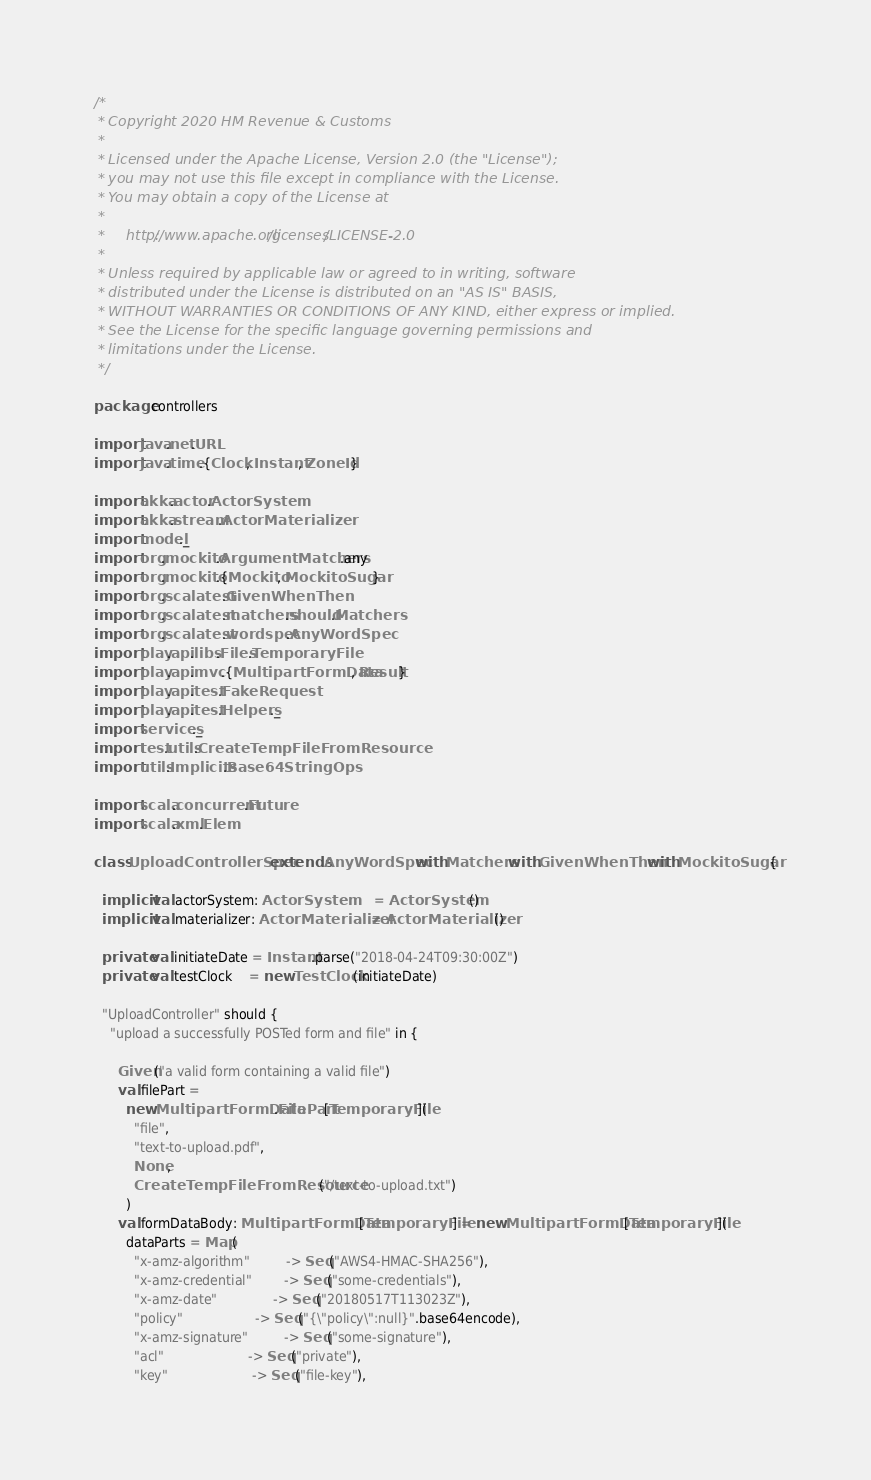<code> <loc_0><loc_0><loc_500><loc_500><_Scala_>/*
 * Copyright 2020 HM Revenue & Customs
 *
 * Licensed under the Apache License, Version 2.0 (the "License");
 * you may not use this file except in compliance with the License.
 * You may obtain a copy of the License at
 *
 *     http://www.apache.org/licenses/LICENSE-2.0
 *
 * Unless required by applicable law or agreed to in writing, software
 * distributed under the License is distributed on an "AS IS" BASIS,
 * WITHOUT WARRANTIES OR CONDITIONS OF ANY KIND, either express or implied.
 * See the License for the specific language governing permissions and
 * limitations under the License.
 */

package controllers

import java.net.URL
import java.time.{Clock, Instant, ZoneId}

import akka.actor.ActorSystem
import akka.stream.ActorMaterializer
import model._
import org.mockito.ArgumentMatchers.any
import org.mockito.{Mockito, MockitoSugar}
import org.scalatest.GivenWhenThen
import org.scalatest.matchers.should.Matchers
import org.scalatest.wordspec.AnyWordSpec
import play.api.libs.Files.TemporaryFile
import play.api.mvc.{MultipartFormData, Result}
import play.api.test.FakeRequest
import play.api.test.Helpers._
import services._
import test.utils.CreateTempFileFromResource
import utils.Implicits.Base64StringOps

import scala.concurrent.Future
import scala.xml.Elem

class UploadControllerSpec extends AnyWordSpec with Matchers with GivenWhenThen with MockitoSugar {

  implicit val actorSystem: ActorSystem        = ActorSystem()
  implicit val materializer: ActorMaterializer = ActorMaterializer()

  private val initiateDate = Instant.parse("2018-04-24T09:30:00Z")
  private val testClock    = new TestClock(initiateDate)

  "UploadController" should {
    "upload a successfully POSTed form and file" in {

      Given("a valid form containing a valid file")
      val filePart =
        new MultipartFormData.FilePart[TemporaryFile](
          "file",
          "text-to-upload.pdf",
          None,
          CreateTempFileFromResource("/text-to-upload.txt")
        )
      val formDataBody: MultipartFormData[TemporaryFile] = new MultipartFormData[TemporaryFile](
        dataParts = Map(
          "x-amz-algorithm"         -> Seq("AWS4-HMAC-SHA256"),
          "x-amz-credential"        -> Seq("some-credentials"),
          "x-amz-date"              -> Seq("20180517T113023Z"),
          "policy"                  -> Seq("{\"policy\":null}".base64encode),
          "x-amz-signature"         -> Seq("some-signature"),
          "acl"                     -> Seq("private"),
          "key"                     -> Seq("file-key"),</code> 